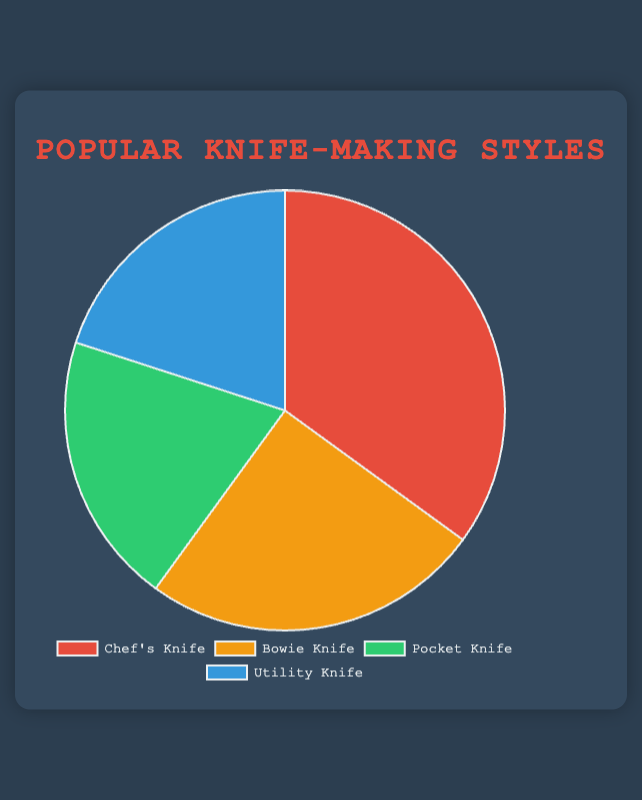What's the most popular knife-making style among art students? The Chef's Knife has the largest portion of the pie, indicating it's the most popular style.
Answer: Chef's Knife Which knife-making styles have the exact same popularity? The Pocket Knife and Utility Knife sections are equally sized in the pie chart.
Answer: Pocket Knife and Utility Knife What percentage of students prefer the Bowie Knife compared to the total percentage of students who prefer the Pocket Knife and Utility Knife combined? The Bowie Knife has 25%, and the combined percentage for Pocket Knife and Utility Knife is 20% + 20% = 40%. So, 25% compared to 40%.
Answer: 25% compared to 40% How much more popular is the Chef's Knife compared to the Pocket Knife? The Chef's Knife is 35% and the Pocket Knife is 20%, so the difference is 35% - 20% = 15%.
Answer: 15% Which section of the pie chart is the smallest? The Pocket Knife and Utility Knife sections are both the smallest as they are equal.
Answer: Pocket Knife and Utility Knife Summing up the percentages of the Pocket Knife, Utility Knife, and Bowie Knife, what is the total? The Pocket Knife and Utility Knife each are 20%, and the Bowie Knife is 25%; summing them up gives 20% + 20% + 25% = 65%.
Answer: 65% Which knife-making styles together make up exactly half of the preferences among art students? The Pocket Knife and Utility Knife both have 20% each, together making 40%, and adding the Bowie Knife's 25% provides 40% + 25% = 65%, which is more than half. The Chef's Knife alone is 35%, so there's no exact combination of styles adding up to 50%.
Answer: None Out of all the knife-making styles, which one has the highest preference after the Chef's Knife? The pie chart shows that after the Chef's Knife, the Bowie Knife has the next highest portion.
Answer: Bowie Knife 